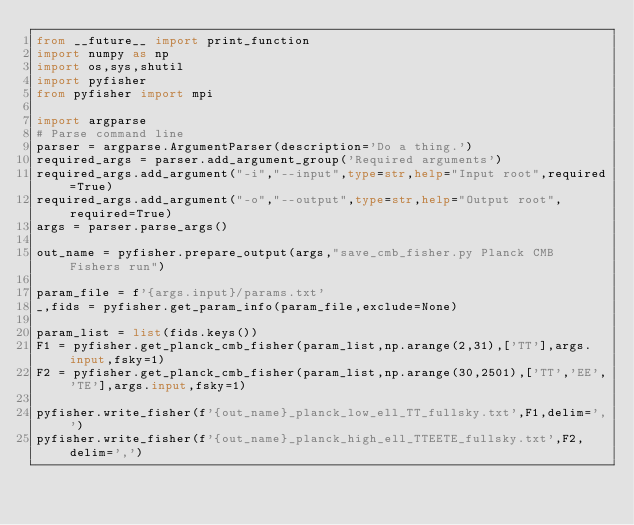<code> <loc_0><loc_0><loc_500><loc_500><_Python_>from __future__ import print_function
import numpy as np
import os,sys,shutil
import pyfisher
from pyfisher import mpi

import argparse
# Parse command line
parser = argparse.ArgumentParser(description='Do a thing.')
required_args = parser.add_argument_group('Required arguments')
required_args.add_argument("-i","--input",type=str,help="Input root",required=True)
required_args.add_argument("-o","--output",type=str,help="Output root",required=True)
args = parser.parse_args()

out_name = pyfisher.prepare_output(args,"save_cmb_fisher.py Planck CMB Fishers run")

param_file = f'{args.input}/params.txt'
_,fids = pyfisher.get_param_info(param_file,exclude=None)

param_list = list(fids.keys())
F1 = pyfisher.get_planck_cmb_fisher(param_list,np.arange(2,31),['TT'],args.input,fsky=1)
F2 = pyfisher.get_planck_cmb_fisher(param_list,np.arange(30,2501),['TT','EE','TE'],args.input,fsky=1)

pyfisher.write_fisher(f'{out_name}_planck_low_ell_TT_fullsky.txt',F1,delim=',')
pyfisher.write_fisher(f'{out_name}_planck_high_ell_TTEETE_fullsky.txt',F2,delim=',')
</code> 